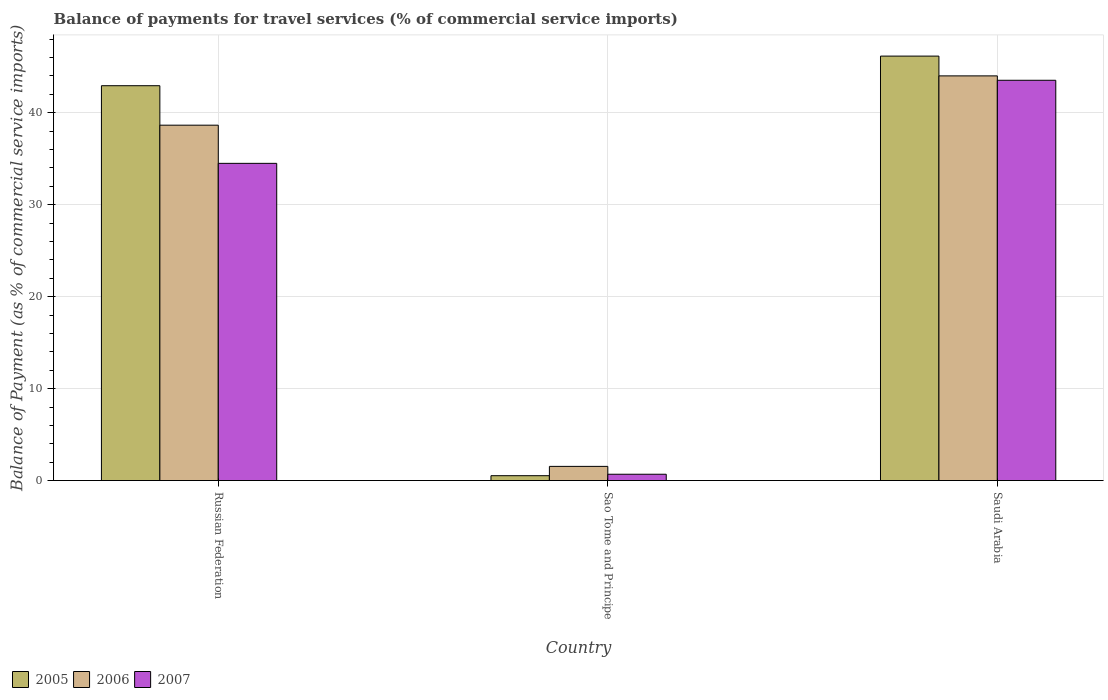How many groups of bars are there?
Your answer should be compact. 3. What is the label of the 3rd group of bars from the left?
Offer a terse response. Saudi Arabia. What is the balance of payments for travel services in 2007 in Saudi Arabia?
Keep it short and to the point. 43.53. Across all countries, what is the maximum balance of payments for travel services in 2006?
Your answer should be compact. 44.01. Across all countries, what is the minimum balance of payments for travel services in 2005?
Your answer should be compact. 0.53. In which country was the balance of payments for travel services in 2007 maximum?
Provide a succinct answer. Saudi Arabia. In which country was the balance of payments for travel services in 2006 minimum?
Offer a very short reply. Sao Tome and Principe. What is the total balance of payments for travel services in 2006 in the graph?
Your answer should be compact. 84.21. What is the difference between the balance of payments for travel services in 2005 in Russian Federation and that in Sao Tome and Principe?
Provide a short and direct response. 42.41. What is the difference between the balance of payments for travel services in 2005 in Russian Federation and the balance of payments for travel services in 2007 in Saudi Arabia?
Keep it short and to the point. -0.59. What is the average balance of payments for travel services in 2007 per country?
Offer a very short reply. 26.24. What is the difference between the balance of payments for travel services of/in 2007 and balance of payments for travel services of/in 2006 in Sao Tome and Principe?
Your answer should be compact. -0.86. In how many countries, is the balance of payments for travel services in 2006 greater than 38 %?
Make the answer very short. 2. What is the ratio of the balance of payments for travel services in 2007 in Sao Tome and Principe to that in Saudi Arabia?
Provide a succinct answer. 0.02. Is the difference between the balance of payments for travel services in 2007 in Russian Federation and Sao Tome and Principe greater than the difference between the balance of payments for travel services in 2006 in Russian Federation and Sao Tome and Principe?
Your response must be concise. No. What is the difference between the highest and the second highest balance of payments for travel services in 2005?
Ensure brevity in your answer.  -42.41. What is the difference between the highest and the lowest balance of payments for travel services in 2005?
Offer a terse response. 45.63. In how many countries, is the balance of payments for travel services in 2007 greater than the average balance of payments for travel services in 2007 taken over all countries?
Make the answer very short. 2. What does the 3rd bar from the left in Saudi Arabia represents?
Ensure brevity in your answer.  2007. What does the 2nd bar from the right in Sao Tome and Principe represents?
Your answer should be compact. 2006. Are all the bars in the graph horizontal?
Keep it short and to the point. No. How many countries are there in the graph?
Give a very brief answer. 3. Are the values on the major ticks of Y-axis written in scientific E-notation?
Your answer should be very brief. No. Does the graph contain grids?
Make the answer very short. Yes. Where does the legend appear in the graph?
Provide a succinct answer. Bottom left. What is the title of the graph?
Ensure brevity in your answer.  Balance of payments for travel services (% of commercial service imports). Does "1960" appear as one of the legend labels in the graph?
Provide a short and direct response. No. What is the label or title of the Y-axis?
Your answer should be very brief. Balance of Payment (as % of commercial service imports). What is the Balance of Payment (as % of commercial service imports) in 2005 in Russian Federation?
Offer a terse response. 42.94. What is the Balance of Payment (as % of commercial service imports) of 2006 in Russian Federation?
Ensure brevity in your answer.  38.65. What is the Balance of Payment (as % of commercial service imports) in 2007 in Russian Federation?
Make the answer very short. 34.5. What is the Balance of Payment (as % of commercial service imports) in 2005 in Sao Tome and Principe?
Your answer should be very brief. 0.53. What is the Balance of Payment (as % of commercial service imports) of 2006 in Sao Tome and Principe?
Your answer should be very brief. 1.54. What is the Balance of Payment (as % of commercial service imports) in 2007 in Sao Tome and Principe?
Offer a terse response. 0.69. What is the Balance of Payment (as % of commercial service imports) in 2005 in Saudi Arabia?
Your answer should be very brief. 46.16. What is the Balance of Payment (as % of commercial service imports) in 2006 in Saudi Arabia?
Offer a very short reply. 44.01. What is the Balance of Payment (as % of commercial service imports) of 2007 in Saudi Arabia?
Your response must be concise. 43.53. Across all countries, what is the maximum Balance of Payment (as % of commercial service imports) of 2005?
Give a very brief answer. 46.16. Across all countries, what is the maximum Balance of Payment (as % of commercial service imports) in 2006?
Keep it short and to the point. 44.01. Across all countries, what is the maximum Balance of Payment (as % of commercial service imports) of 2007?
Ensure brevity in your answer.  43.53. Across all countries, what is the minimum Balance of Payment (as % of commercial service imports) in 2005?
Provide a short and direct response. 0.53. Across all countries, what is the minimum Balance of Payment (as % of commercial service imports) of 2006?
Give a very brief answer. 1.54. Across all countries, what is the minimum Balance of Payment (as % of commercial service imports) of 2007?
Give a very brief answer. 0.69. What is the total Balance of Payment (as % of commercial service imports) of 2005 in the graph?
Provide a short and direct response. 89.64. What is the total Balance of Payment (as % of commercial service imports) in 2006 in the graph?
Provide a short and direct response. 84.21. What is the total Balance of Payment (as % of commercial service imports) of 2007 in the graph?
Ensure brevity in your answer.  78.72. What is the difference between the Balance of Payment (as % of commercial service imports) in 2005 in Russian Federation and that in Sao Tome and Principe?
Offer a very short reply. 42.41. What is the difference between the Balance of Payment (as % of commercial service imports) in 2006 in Russian Federation and that in Sao Tome and Principe?
Offer a terse response. 37.11. What is the difference between the Balance of Payment (as % of commercial service imports) in 2007 in Russian Federation and that in Sao Tome and Principe?
Provide a short and direct response. 33.81. What is the difference between the Balance of Payment (as % of commercial service imports) in 2005 in Russian Federation and that in Saudi Arabia?
Ensure brevity in your answer.  -3.22. What is the difference between the Balance of Payment (as % of commercial service imports) in 2006 in Russian Federation and that in Saudi Arabia?
Provide a succinct answer. -5.36. What is the difference between the Balance of Payment (as % of commercial service imports) of 2007 in Russian Federation and that in Saudi Arabia?
Your answer should be very brief. -9.03. What is the difference between the Balance of Payment (as % of commercial service imports) in 2005 in Sao Tome and Principe and that in Saudi Arabia?
Ensure brevity in your answer.  -45.63. What is the difference between the Balance of Payment (as % of commercial service imports) of 2006 in Sao Tome and Principe and that in Saudi Arabia?
Offer a very short reply. -42.47. What is the difference between the Balance of Payment (as % of commercial service imports) of 2007 in Sao Tome and Principe and that in Saudi Arabia?
Make the answer very short. -42.85. What is the difference between the Balance of Payment (as % of commercial service imports) in 2005 in Russian Federation and the Balance of Payment (as % of commercial service imports) in 2006 in Sao Tome and Principe?
Your answer should be very brief. 41.4. What is the difference between the Balance of Payment (as % of commercial service imports) of 2005 in Russian Federation and the Balance of Payment (as % of commercial service imports) of 2007 in Sao Tome and Principe?
Keep it short and to the point. 42.26. What is the difference between the Balance of Payment (as % of commercial service imports) of 2006 in Russian Federation and the Balance of Payment (as % of commercial service imports) of 2007 in Sao Tome and Principe?
Provide a succinct answer. 37.96. What is the difference between the Balance of Payment (as % of commercial service imports) of 2005 in Russian Federation and the Balance of Payment (as % of commercial service imports) of 2006 in Saudi Arabia?
Your answer should be compact. -1.07. What is the difference between the Balance of Payment (as % of commercial service imports) of 2005 in Russian Federation and the Balance of Payment (as % of commercial service imports) of 2007 in Saudi Arabia?
Provide a short and direct response. -0.59. What is the difference between the Balance of Payment (as % of commercial service imports) in 2006 in Russian Federation and the Balance of Payment (as % of commercial service imports) in 2007 in Saudi Arabia?
Your response must be concise. -4.88. What is the difference between the Balance of Payment (as % of commercial service imports) of 2005 in Sao Tome and Principe and the Balance of Payment (as % of commercial service imports) of 2006 in Saudi Arabia?
Provide a short and direct response. -43.48. What is the difference between the Balance of Payment (as % of commercial service imports) of 2005 in Sao Tome and Principe and the Balance of Payment (as % of commercial service imports) of 2007 in Saudi Arabia?
Provide a short and direct response. -43. What is the difference between the Balance of Payment (as % of commercial service imports) in 2006 in Sao Tome and Principe and the Balance of Payment (as % of commercial service imports) in 2007 in Saudi Arabia?
Provide a short and direct response. -41.99. What is the average Balance of Payment (as % of commercial service imports) in 2005 per country?
Make the answer very short. 29.88. What is the average Balance of Payment (as % of commercial service imports) of 2006 per country?
Provide a short and direct response. 28.07. What is the average Balance of Payment (as % of commercial service imports) of 2007 per country?
Provide a succinct answer. 26.24. What is the difference between the Balance of Payment (as % of commercial service imports) of 2005 and Balance of Payment (as % of commercial service imports) of 2006 in Russian Federation?
Offer a very short reply. 4.29. What is the difference between the Balance of Payment (as % of commercial service imports) of 2005 and Balance of Payment (as % of commercial service imports) of 2007 in Russian Federation?
Your answer should be very brief. 8.44. What is the difference between the Balance of Payment (as % of commercial service imports) in 2006 and Balance of Payment (as % of commercial service imports) in 2007 in Russian Federation?
Provide a short and direct response. 4.15. What is the difference between the Balance of Payment (as % of commercial service imports) in 2005 and Balance of Payment (as % of commercial service imports) in 2006 in Sao Tome and Principe?
Your response must be concise. -1.01. What is the difference between the Balance of Payment (as % of commercial service imports) in 2005 and Balance of Payment (as % of commercial service imports) in 2007 in Sao Tome and Principe?
Make the answer very short. -0.16. What is the difference between the Balance of Payment (as % of commercial service imports) in 2006 and Balance of Payment (as % of commercial service imports) in 2007 in Sao Tome and Principe?
Give a very brief answer. 0.86. What is the difference between the Balance of Payment (as % of commercial service imports) of 2005 and Balance of Payment (as % of commercial service imports) of 2006 in Saudi Arabia?
Provide a short and direct response. 2.15. What is the difference between the Balance of Payment (as % of commercial service imports) in 2005 and Balance of Payment (as % of commercial service imports) in 2007 in Saudi Arabia?
Your response must be concise. 2.63. What is the difference between the Balance of Payment (as % of commercial service imports) in 2006 and Balance of Payment (as % of commercial service imports) in 2007 in Saudi Arabia?
Provide a short and direct response. 0.48. What is the ratio of the Balance of Payment (as % of commercial service imports) of 2005 in Russian Federation to that in Sao Tome and Principe?
Your answer should be compact. 80.75. What is the ratio of the Balance of Payment (as % of commercial service imports) in 2006 in Russian Federation to that in Sao Tome and Principe?
Give a very brief answer. 25.04. What is the ratio of the Balance of Payment (as % of commercial service imports) in 2007 in Russian Federation to that in Sao Tome and Principe?
Your answer should be very brief. 50.13. What is the ratio of the Balance of Payment (as % of commercial service imports) of 2005 in Russian Federation to that in Saudi Arabia?
Provide a succinct answer. 0.93. What is the ratio of the Balance of Payment (as % of commercial service imports) of 2006 in Russian Federation to that in Saudi Arabia?
Your answer should be very brief. 0.88. What is the ratio of the Balance of Payment (as % of commercial service imports) in 2007 in Russian Federation to that in Saudi Arabia?
Offer a terse response. 0.79. What is the ratio of the Balance of Payment (as % of commercial service imports) in 2005 in Sao Tome and Principe to that in Saudi Arabia?
Your answer should be compact. 0.01. What is the ratio of the Balance of Payment (as % of commercial service imports) in 2006 in Sao Tome and Principe to that in Saudi Arabia?
Your answer should be very brief. 0.04. What is the ratio of the Balance of Payment (as % of commercial service imports) in 2007 in Sao Tome and Principe to that in Saudi Arabia?
Provide a short and direct response. 0.02. What is the difference between the highest and the second highest Balance of Payment (as % of commercial service imports) in 2005?
Ensure brevity in your answer.  3.22. What is the difference between the highest and the second highest Balance of Payment (as % of commercial service imports) of 2006?
Provide a succinct answer. 5.36. What is the difference between the highest and the second highest Balance of Payment (as % of commercial service imports) in 2007?
Keep it short and to the point. 9.03. What is the difference between the highest and the lowest Balance of Payment (as % of commercial service imports) of 2005?
Your answer should be very brief. 45.63. What is the difference between the highest and the lowest Balance of Payment (as % of commercial service imports) of 2006?
Your answer should be very brief. 42.47. What is the difference between the highest and the lowest Balance of Payment (as % of commercial service imports) in 2007?
Your answer should be very brief. 42.85. 